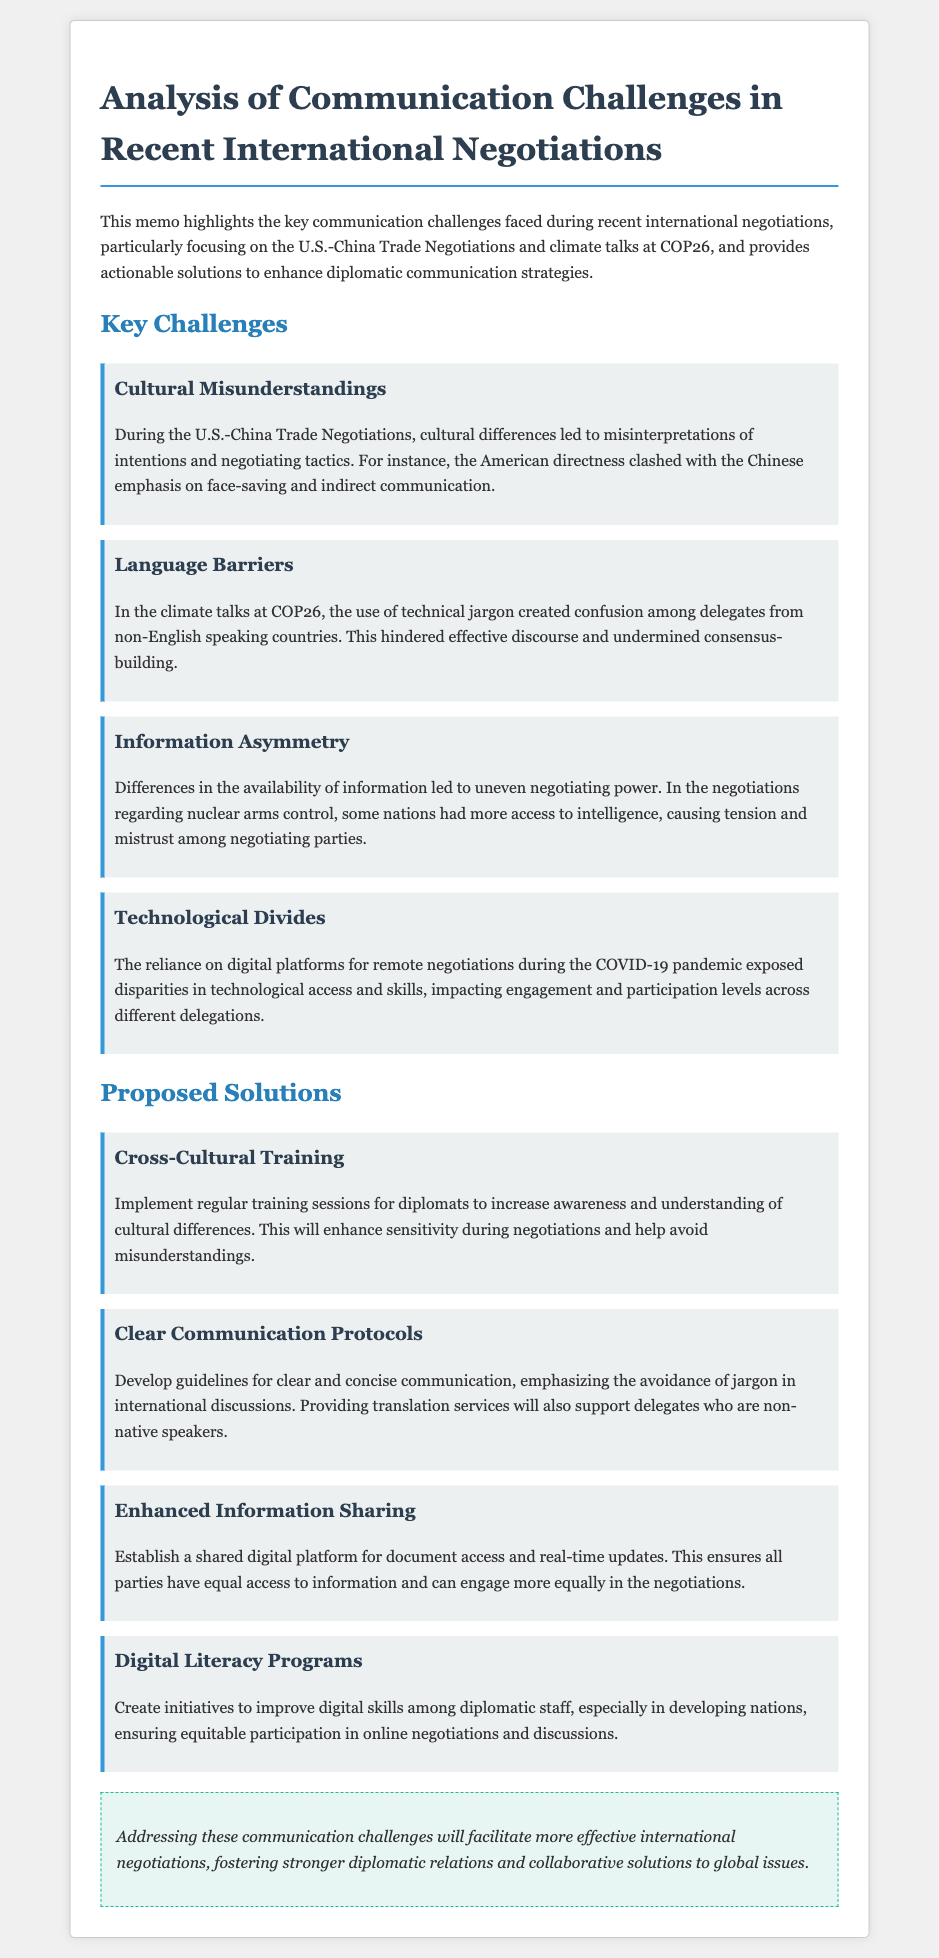What was the primary focus of the memo? The memo highlights the key communication challenges faced during recent international negotiations and provides actionable solutions.
Answer: Communication challenges What are the two specific international negotiations mentioned? The memo references the U.S.-China Trade Negotiations and climate talks at COP26.
Answer: U.S.-China Trade Negotiations, COP26 What cultural issue was highlighted during the U.S.-China Trade Negotiations? The directness of American negotiators clashed with the Chinese emphasis on face-saving and indirect communication.
Answer: Cultural misunderstandings What is one proposed solution to address cultural misunderstandings? The memo suggests implementing regular training sessions for diplomats to increase awareness and understanding of cultural differences.
Answer: Cross-Cultural Training What aspect of negotiation does language serve as a barrier to according to the COP26 discussions? The use of technical jargon among delegates from non-English speaking countries created confusion and hindered effective discourse.
Answer: Consensus-building What is a key challenge related to technology as noted in the document? The reliance on digital platforms for remote negotiations during the COVID-19 pandemic exposed disparities in technological access and skills.
Answer: Technological divides How many proposed solutions are listed in the memo? The memo lists four proposed solutions to address communication challenges.
Answer: Four What does the conclusion emphasize regarding the communication challenges? Addressing these communication challenges will facilitate more effective international negotiations.
Answer: Effective international negotiations 